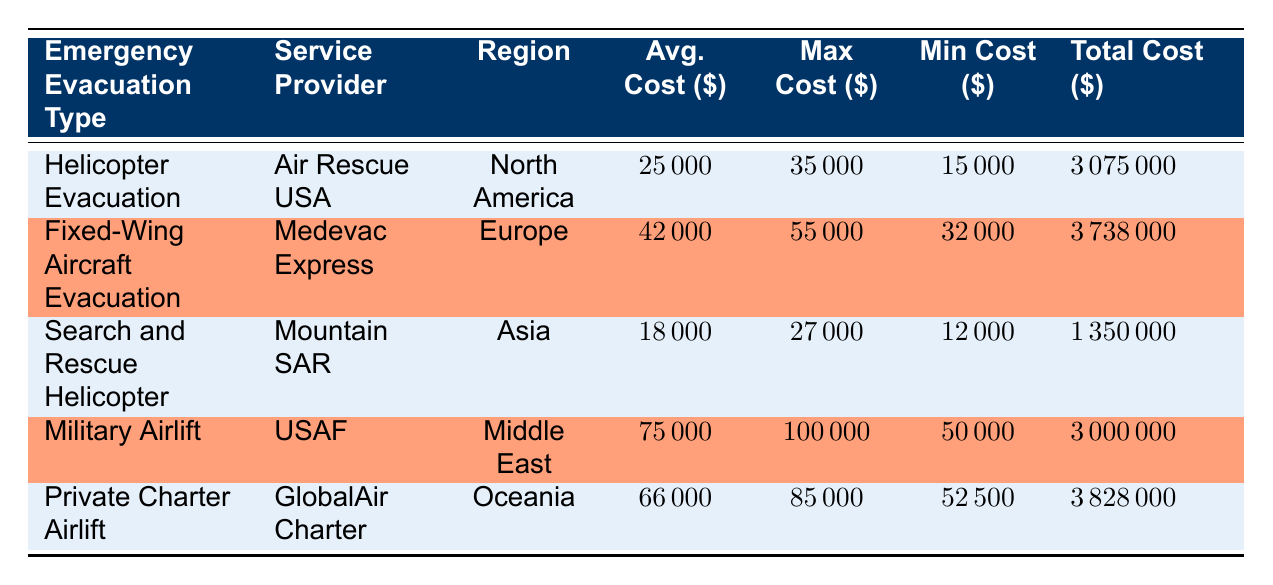What is the average cost for a Military Airlift? The average cost for a Military Airlift is listed in the table under the "Avg. Cost" column, which shows 75000.
Answer: 75000 Which evacuation type had the highest maximum cost recorded? Looking at the "Max Cost Recorded" column, the Military Airlift shows the highest maximum cost at 100000.
Answer: Military Airlift How many more evacuations were conducted for Helicopter Evacuations compared to Search and Rescue Helicopters? The number of Helicopter Evacuations conducted is 123, and the Search and Rescue Helicopters conducted is 75. The difference is 123 - 75 = 48.
Answer: 48 Is it true that the region with the highest average cost per evacuation is the Middle East? The table shows the average costs per evacuation with Middle East at 75000 and Europe at 42000. Therefore, it is false as the Middle East does not have the highest average cost.
Answer: No What is the total cost for all types of evacuations combined? To get the total, we sum the "Total Cost" for all entries: 3075000 + 3738000 + 1350000 + 3000000 + 3828000 = 17981000.
Answer: 17981000 What is the minimum cost recorded for Private Charter Airlift? The minimum cost for Private Charter Airlift is stated in the "Min Cost Recorded" column, which is 52500.
Answer: 52500 Which service provider conducted the most evacuations and how many? Referring to the "Number of Evacuations Conducted," Air Rescue USA had the most with 123 evacuations.
Answer: Air Rescue USA, 123 What was the average cost per evacuation for Search and Rescue Helicopters? The average cost for Search and Rescue Helicopters can be found in the "Avg. Cost" column, and it's listed as 18000.
Answer: 18000 If we add the total costs of Helicopter Evacuations and Search and Rescue Helicopters, what is the result? We find the total costs of Helicopter Evacuations (3075000) and Search and Rescue Helicopters (1350000), and sum them: 3075000 + 1350000 = 4425000.
Answer: 4425000 